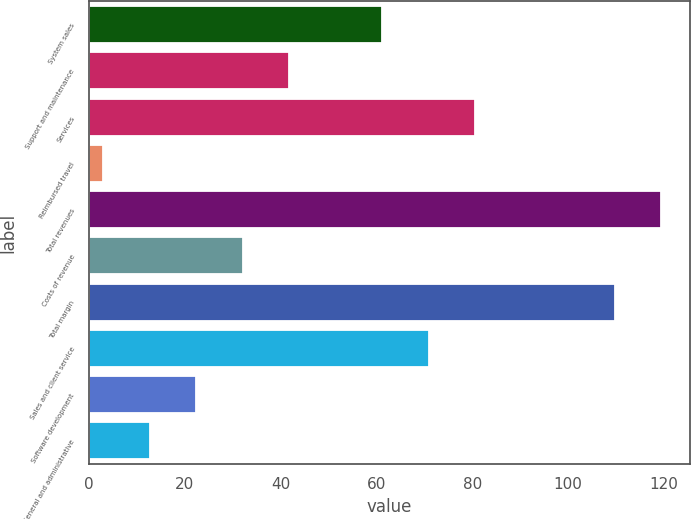<chart> <loc_0><loc_0><loc_500><loc_500><bar_chart><fcel>System sales<fcel>Support and maintenance<fcel>Services<fcel>Reimbursed travel<fcel>Total revenues<fcel>Costs of revenue<fcel>Total margin<fcel>Sales and client service<fcel>Software development<fcel>General and administrative<nl><fcel>61.2<fcel>41.8<fcel>80.6<fcel>3<fcel>119.4<fcel>32.1<fcel>109.7<fcel>70.9<fcel>22.4<fcel>12.7<nl></chart> 